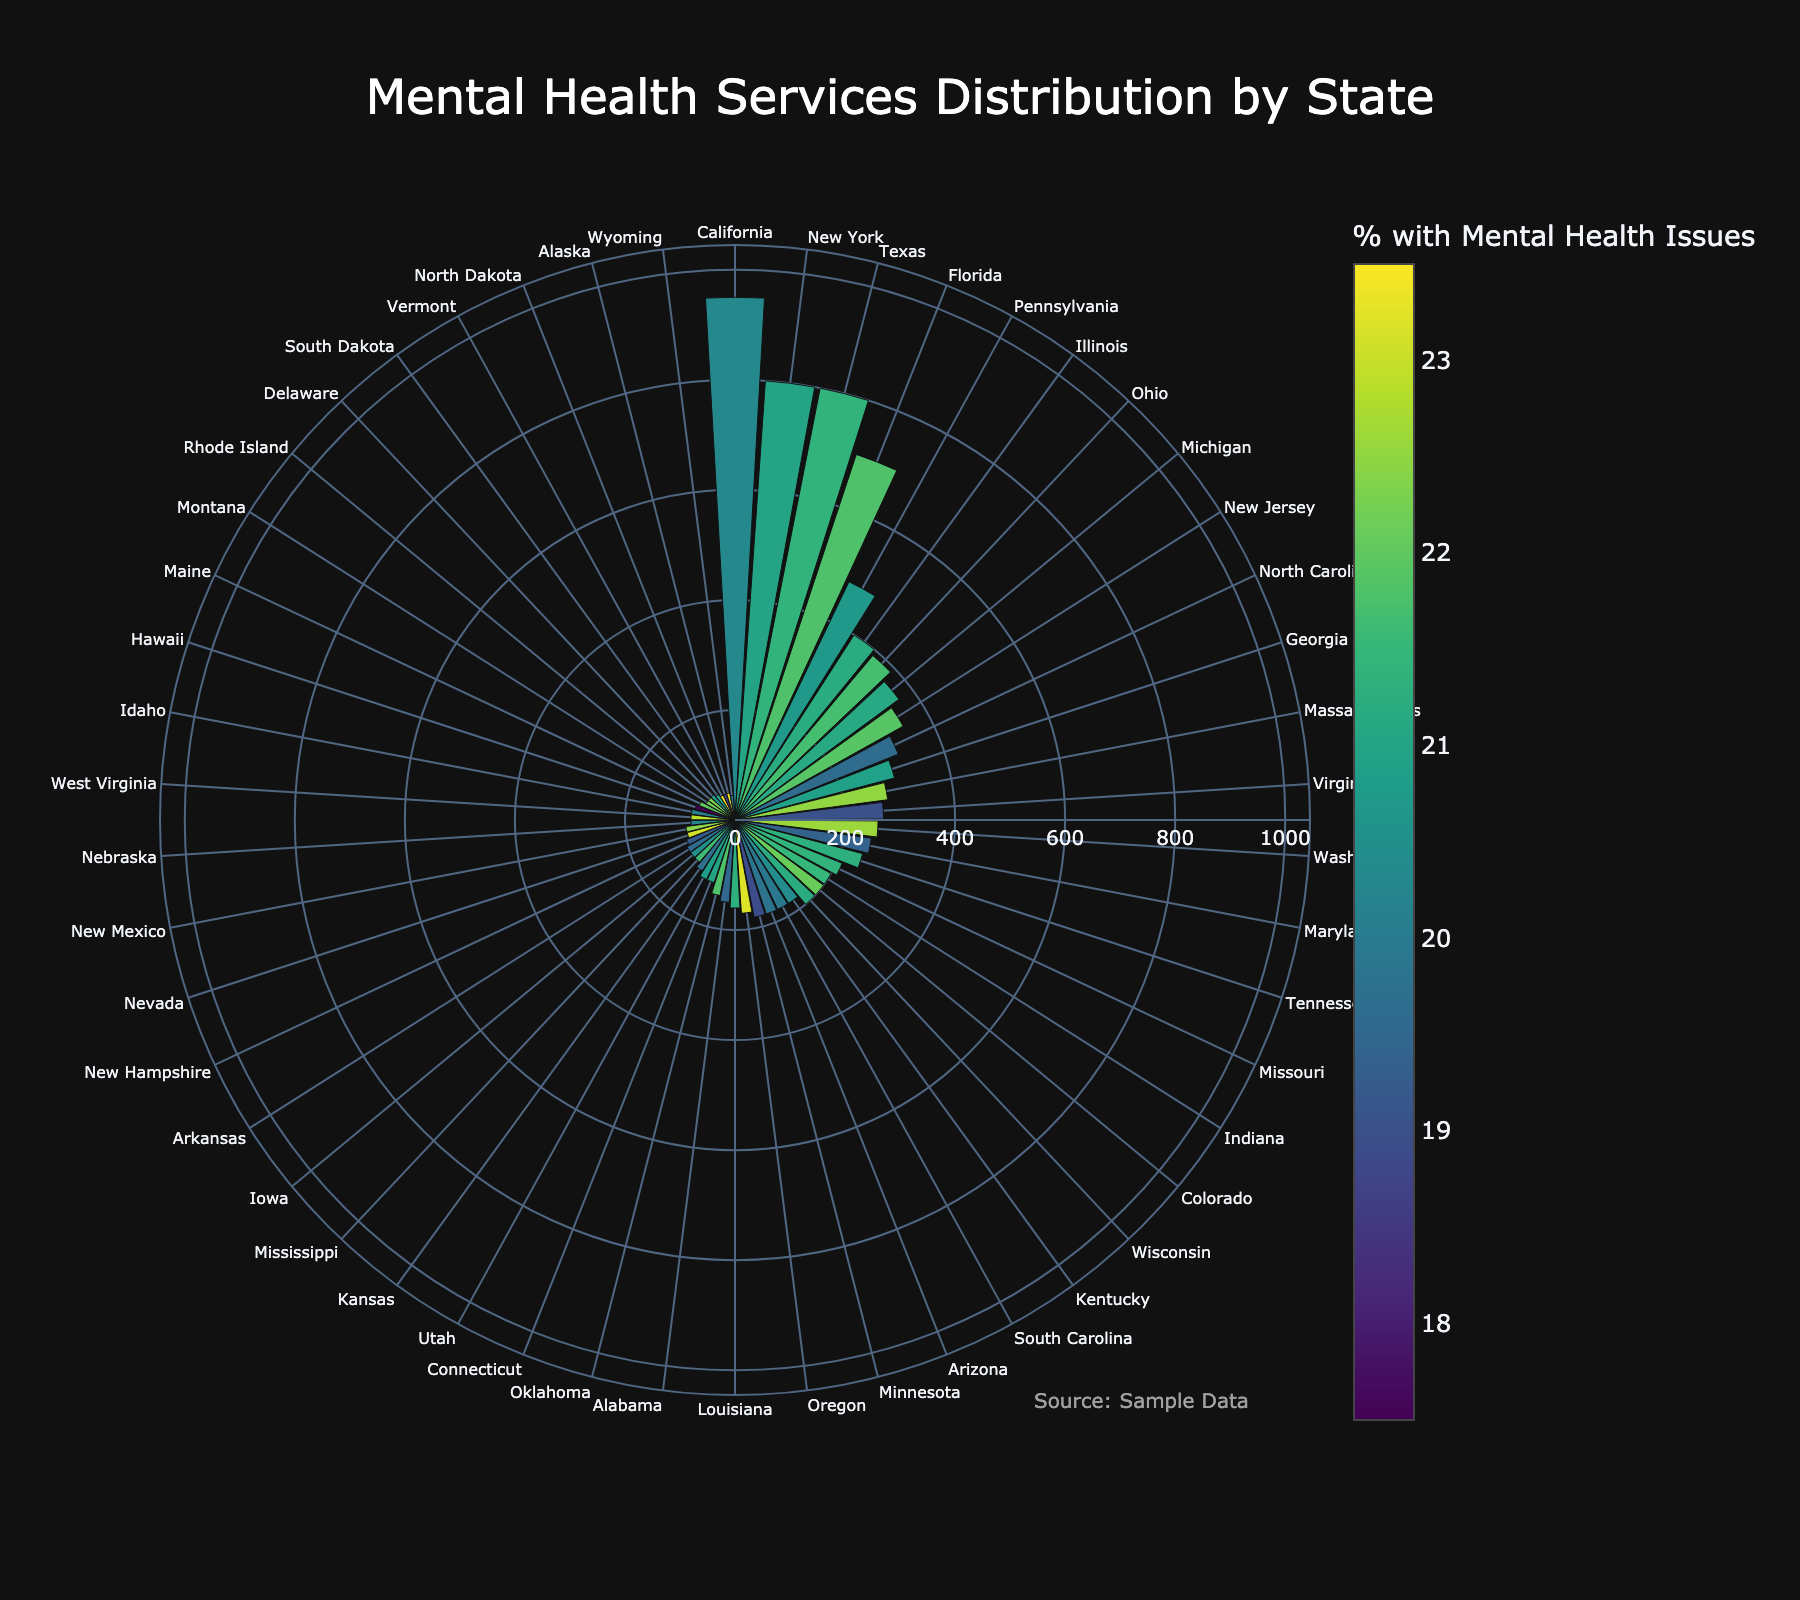What is the state with the highest number of mental health facilities? Look for the state corresponding to the maximum value on the radial axis representing the number of mental health facilities.
Answer: California What is the title of the figure? The title is usually located at the top of the figure and provides a summary of what the figure represents.
Answer: Mental Health Services Distribution by State How many states have more than 300 mental health facilities? Count the number of bars that extend beyond the 300 mark on the radial axis.
Answer: 5 Which state has the smallest number of mental health facilities? Identify the smallest bar, which represents the state with the least number of mental health facilities.
Answer: Wyoming What is the population per facility in Florida? Hover over or refer to the hovertemplate data for Florida to find the population per facility value.
Answer: 42857 How does the number of mental health facilities in Texas compare to New York? Compare the lengths of the bars corresponding to Texas and New York.
Answer: Texas has the same number as New York Which state has the highest percentage of the population with mental health issues and how many facilities does it have? Look for the maximum color value on the colorscale and find the corresponding state on the figure.
Answer: Vermont, 50 